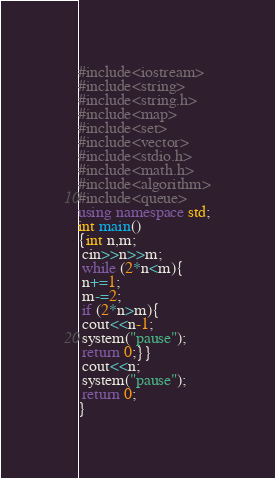Convert code to text. <code><loc_0><loc_0><loc_500><loc_500><_C++_>#include<iostream>
#include<string>
#include<string.h>
#include<map>
#include<set>
#include<vector>
#include<stdio.h>
#include<math.h>
#include<algorithm>
#include<queue> 
using namespace std;
int main() 
{int n,m;
 cin>>n>>m;
 while (2*n<m){
 n+=1;
 m-=2;
 if (2*n>m){
 cout<<n-1;
 system("pause");
 return 0;}}
 cout<<n;
 system("pause");
 return 0;
}        </code> 